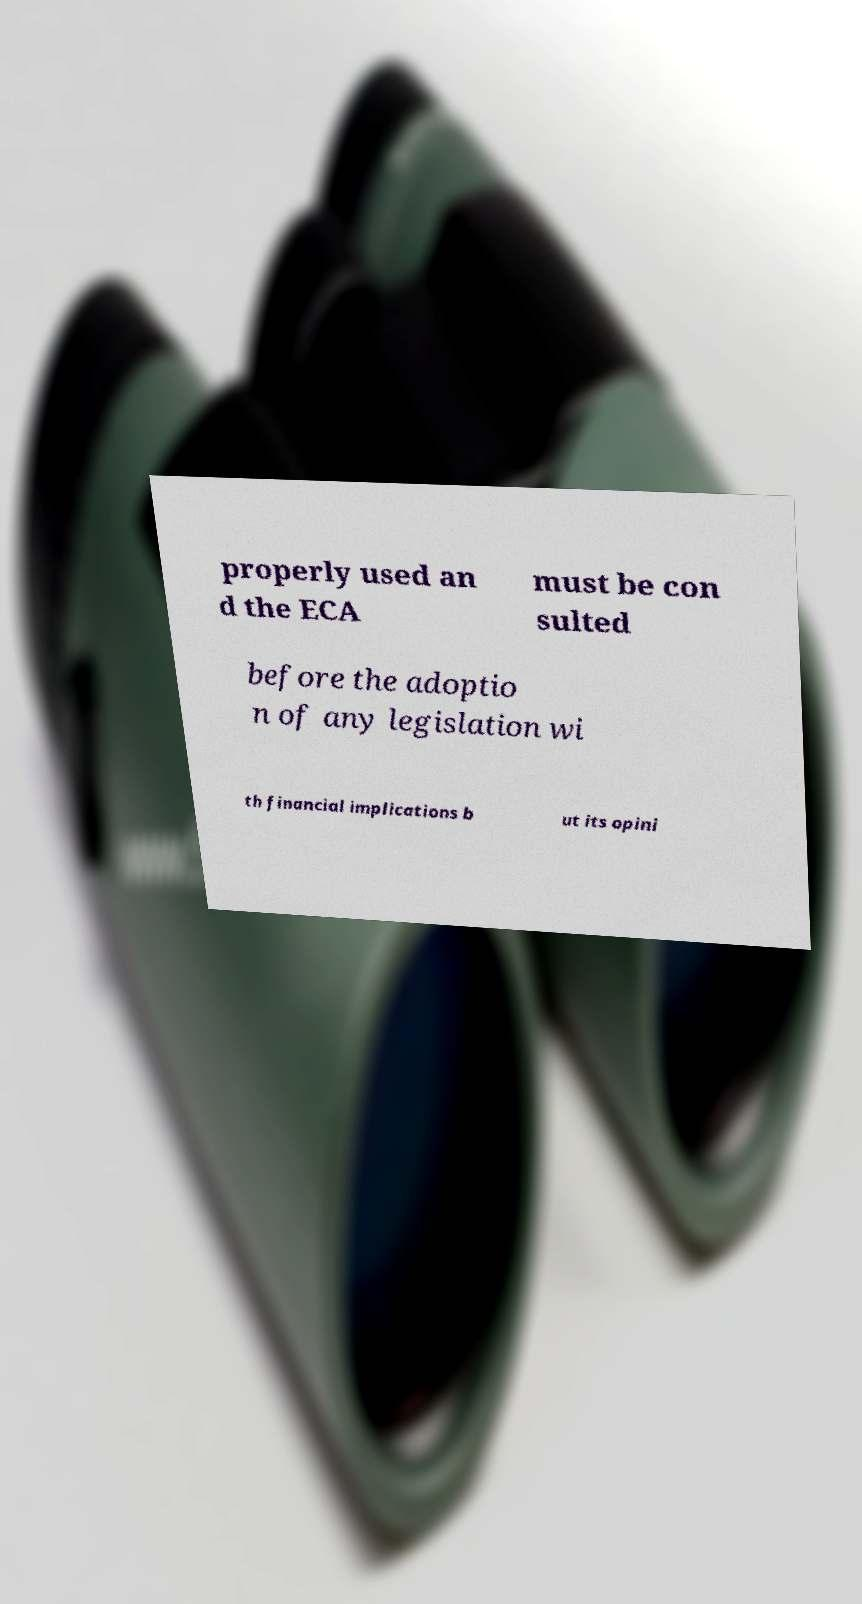Can you read and provide the text displayed in the image?This photo seems to have some interesting text. Can you extract and type it out for me? properly used an d the ECA must be con sulted before the adoptio n of any legislation wi th financial implications b ut its opini 